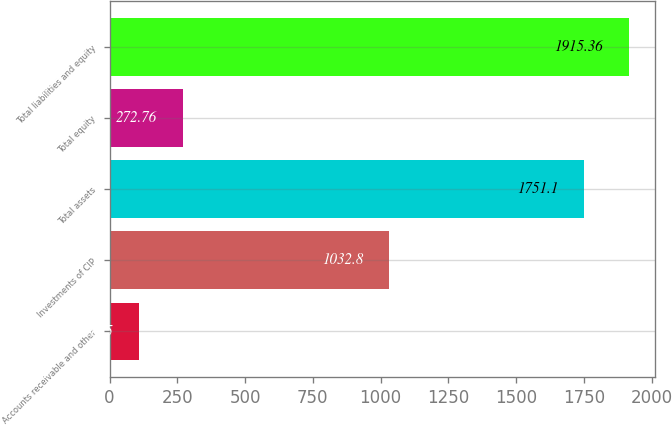Convert chart. <chart><loc_0><loc_0><loc_500><loc_500><bar_chart><fcel>Accounts receivable and other<fcel>Investments of CIP<fcel>Total assets<fcel>Total equity<fcel>Total liabilities and equity<nl><fcel>108.5<fcel>1032.8<fcel>1751.1<fcel>272.76<fcel>1915.36<nl></chart> 